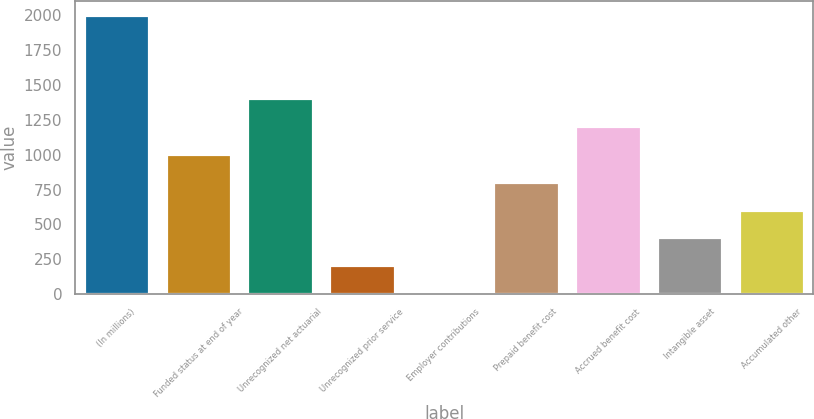<chart> <loc_0><loc_0><loc_500><loc_500><bar_chart><fcel>(In millions)<fcel>Funded status at end of year<fcel>Unrecognized net actuarial<fcel>Unrecognized prior service<fcel>Employer contributions<fcel>Prepaid benefit cost<fcel>Accrued benefit cost<fcel>Intangible asset<fcel>Accumulated other<nl><fcel>2006<fcel>1006<fcel>1406<fcel>206<fcel>6<fcel>806<fcel>1206<fcel>406<fcel>606<nl></chart> 